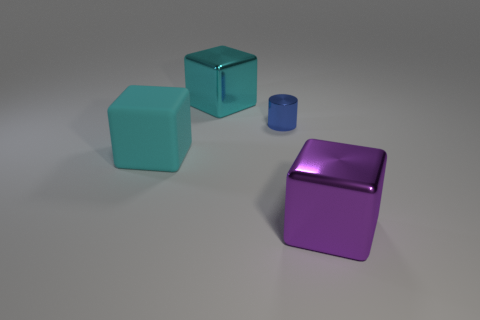What material is the cylinder?
Keep it short and to the point. Metal. There is a big metallic thing behind the big purple shiny cube; what shape is it?
Keep it short and to the point. Cube. What color is the other shiny cube that is the same size as the purple metallic block?
Your answer should be very brief. Cyan. Are the big cyan cube that is on the right side of the big cyan matte block and the purple thing made of the same material?
Keep it short and to the point. Yes. What is the size of the cube that is right of the rubber object and in front of the small metal cylinder?
Your answer should be very brief. Large. How big is the cube that is in front of the matte object?
Offer a very short reply. Large. The other thing that is the same color as the big matte thing is what shape?
Offer a very short reply. Cube. What shape is the big shiny object behind the metal cube in front of the metal thing on the left side of the tiny blue cylinder?
Your answer should be very brief. Cube. What number of other objects are there of the same shape as the blue metallic thing?
Ensure brevity in your answer.  0. What number of matte things are either purple objects or yellow cubes?
Make the answer very short. 0. 